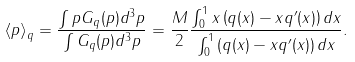Convert formula to latex. <formula><loc_0><loc_0><loc_500><loc_500>\left \langle p \right \rangle _ { q } = \frac { \int p G _ { q } ( p ) d ^ { 3 } p } { \int G _ { q } ( p ) d ^ { 3 } p } = \frac { M } { 2 } \frac { \int _ { 0 } ^ { 1 } x \left ( q ( x ) - x q ^ { \prime } ( x ) \right ) d x } { \int _ { 0 } ^ { 1 } \left ( q ( x ) - x q ^ { \prime } ( x ) \right ) d x } .</formula> 